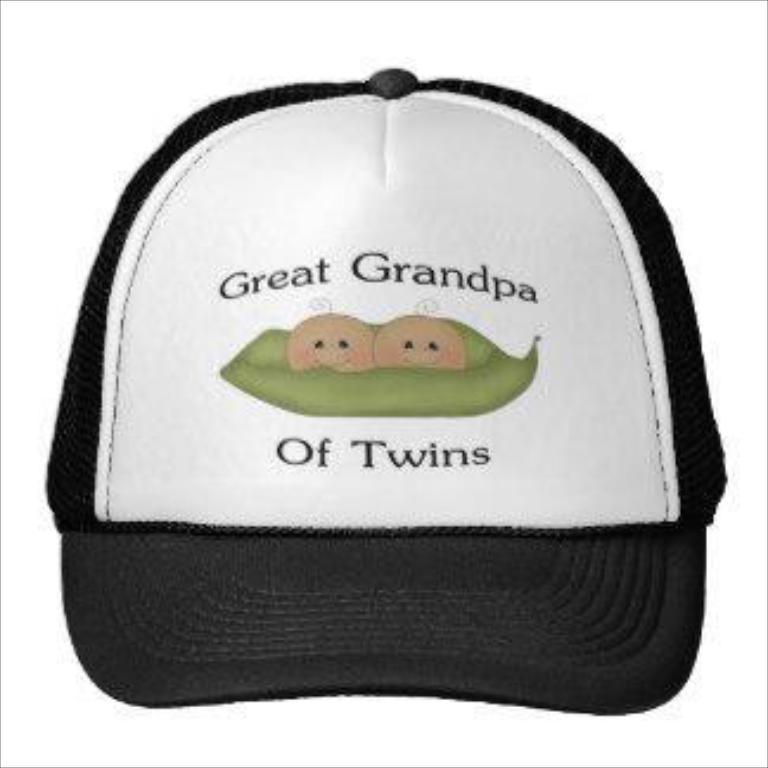Describe this image in one or two sentences. In this image I can see the cap which is in white and black color. I can see something is written on the cap. I can see there is a white background. 